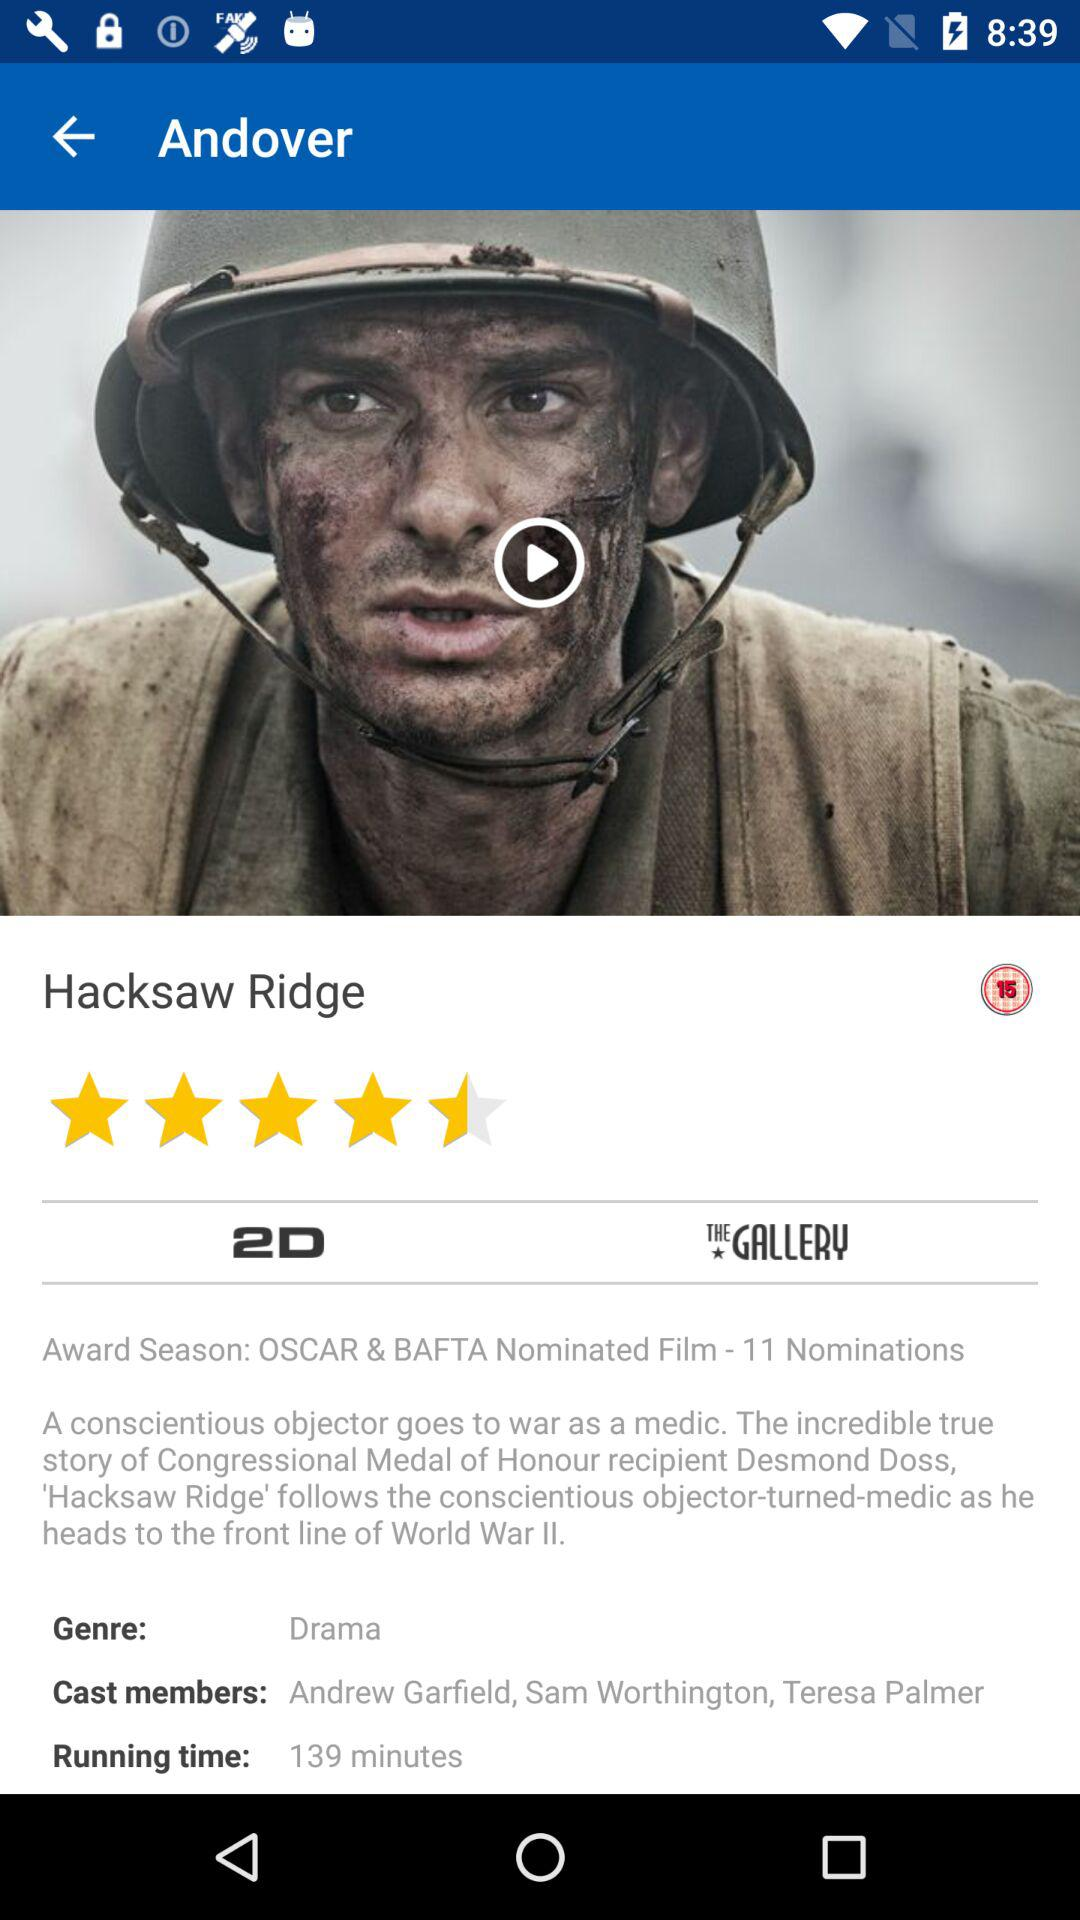What is the rating? The rating is 4.5 stars. 